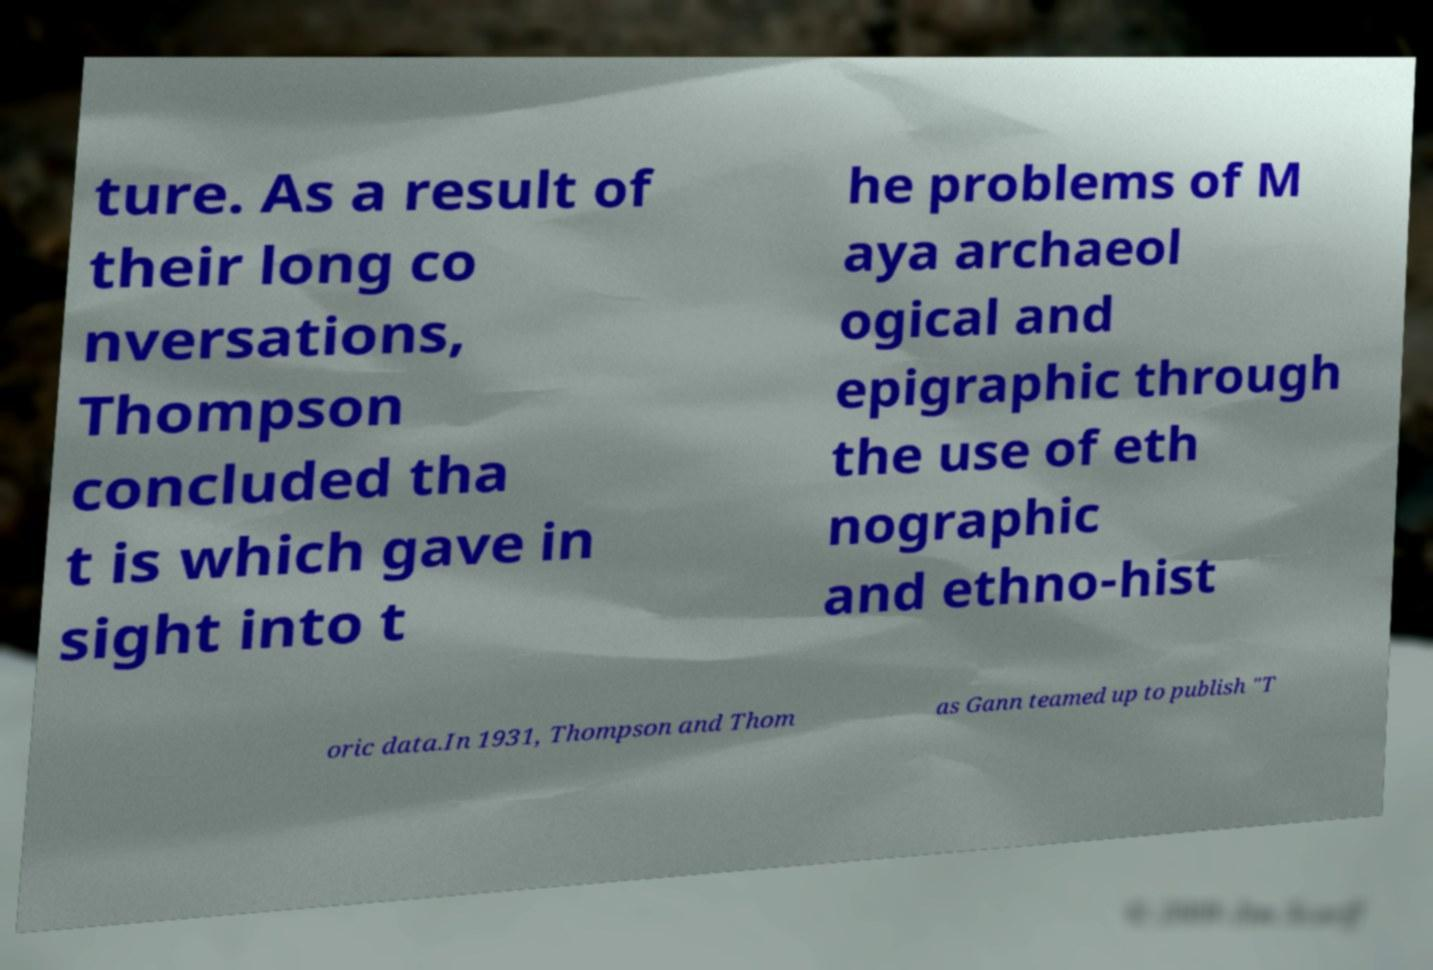I need the written content from this picture converted into text. Can you do that? ture. As a result of their long co nversations, Thompson concluded tha t is which gave in sight into t he problems of M aya archaeol ogical and epigraphic through the use of eth nographic and ethno-hist oric data.In 1931, Thompson and Thom as Gann teamed up to publish "T 